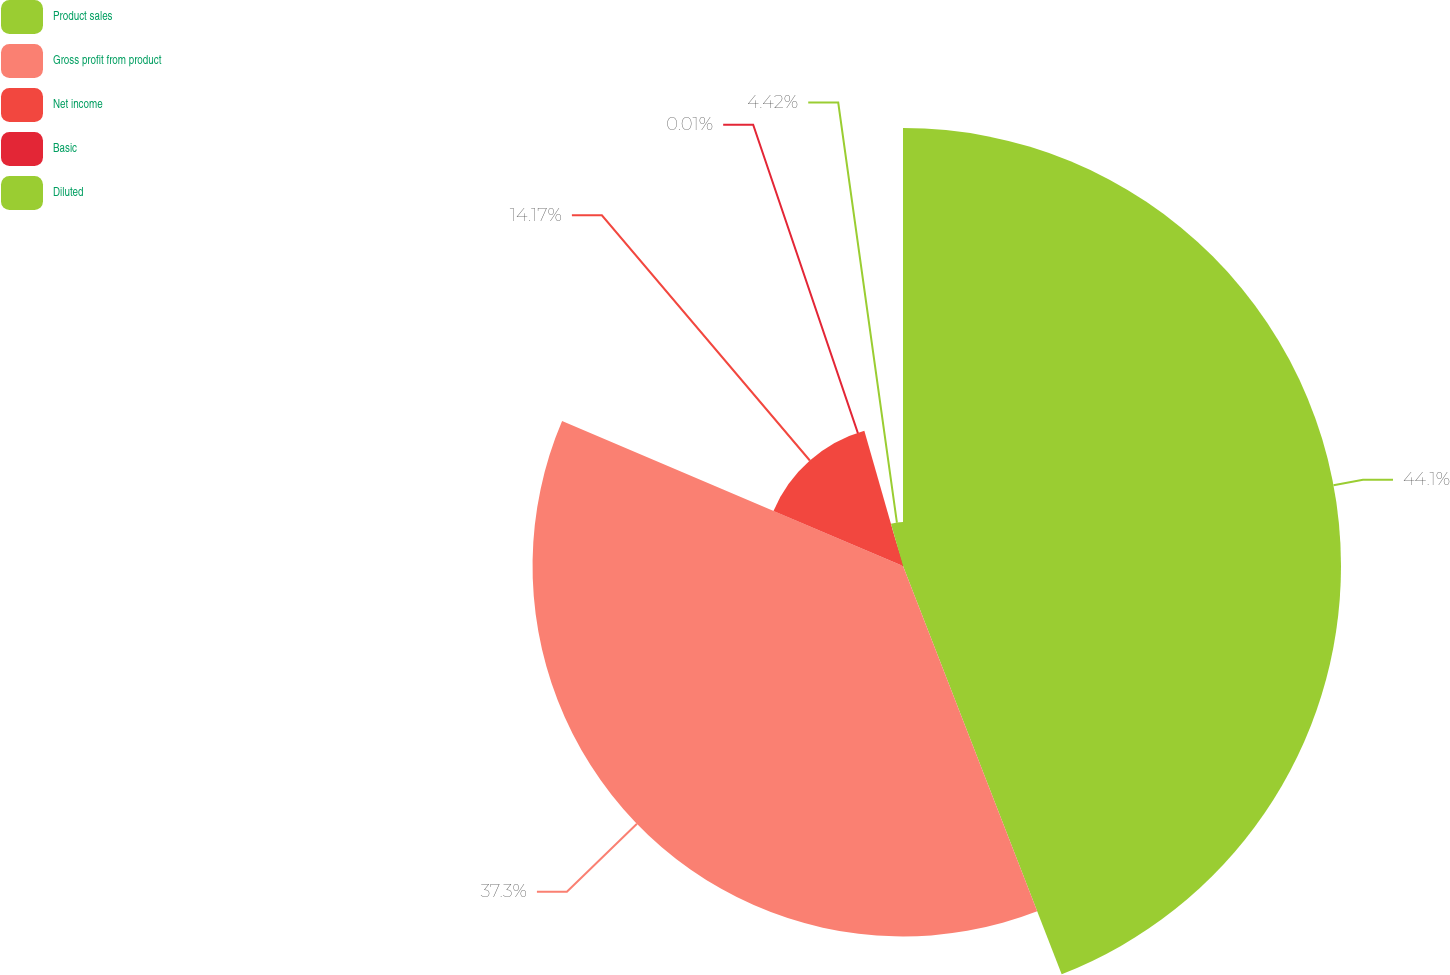<chart> <loc_0><loc_0><loc_500><loc_500><pie_chart><fcel>Product sales<fcel>Gross profit from product<fcel>Net income<fcel>Basic<fcel>Diluted<nl><fcel>44.1%<fcel>37.3%<fcel>14.17%<fcel>0.01%<fcel>4.42%<nl></chart> 